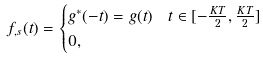Convert formula to latex. <formula><loc_0><loc_0><loc_500><loc_500>f _ { , s } ( t ) & = \begin{cases} g ^ { * } ( - t ) = g ( t ) & t \in [ - \frac { K T } { 2 } , \frac { K T } { 2 } ] \\ 0 , & \end{cases}</formula> 